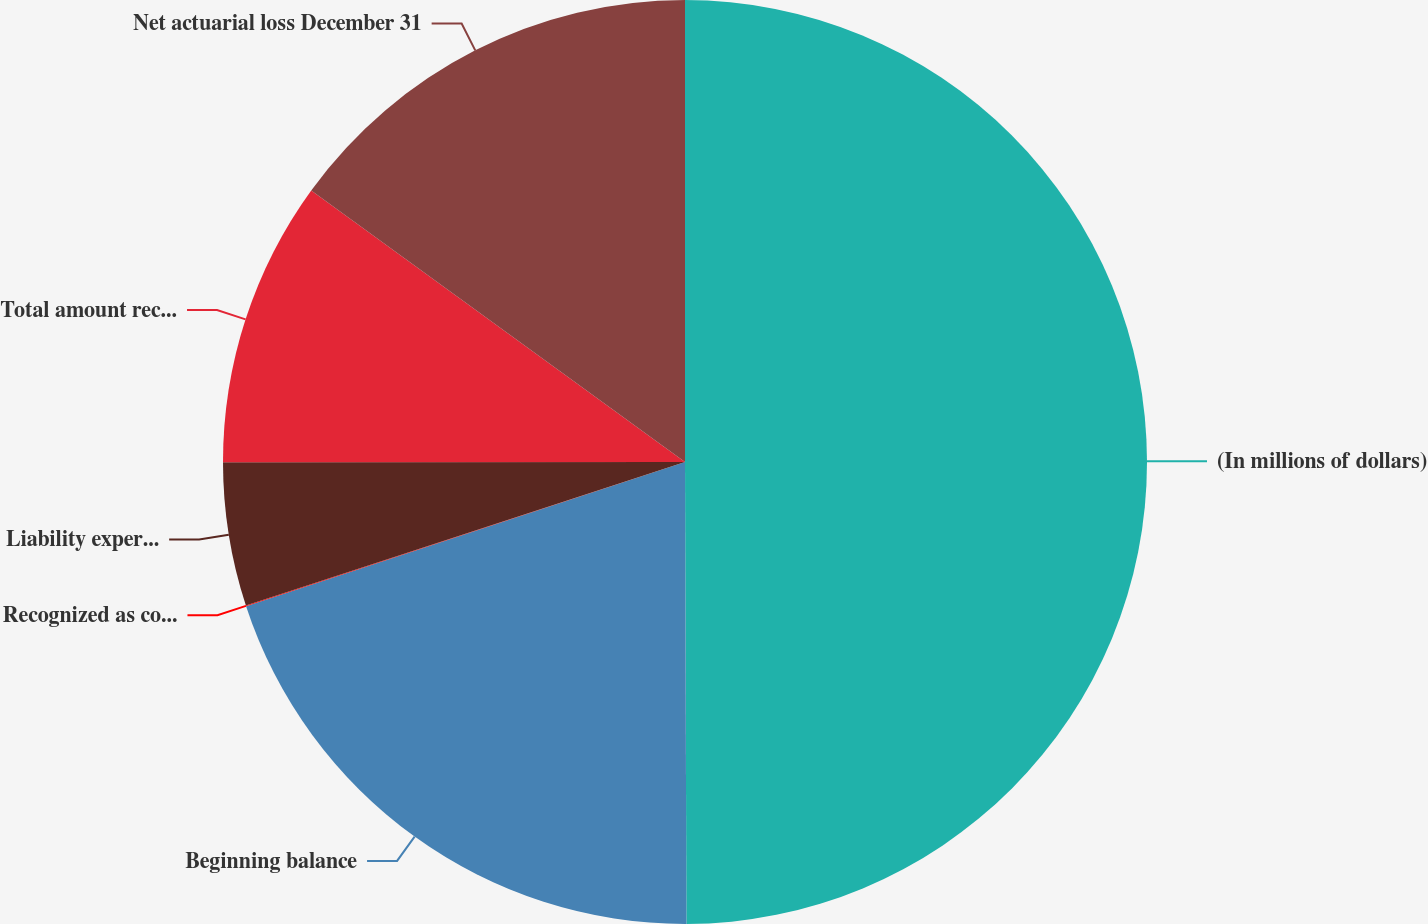<chart> <loc_0><loc_0><loc_500><loc_500><pie_chart><fcel>(In millions of dollars)<fcel>Beginning balance<fcel>Recognized as component of net<fcel>Liability experience<fcel>Total amount recognized as<fcel>Net actuarial loss December 31<nl><fcel>49.95%<fcel>20.0%<fcel>0.02%<fcel>5.02%<fcel>10.01%<fcel>15.0%<nl></chart> 